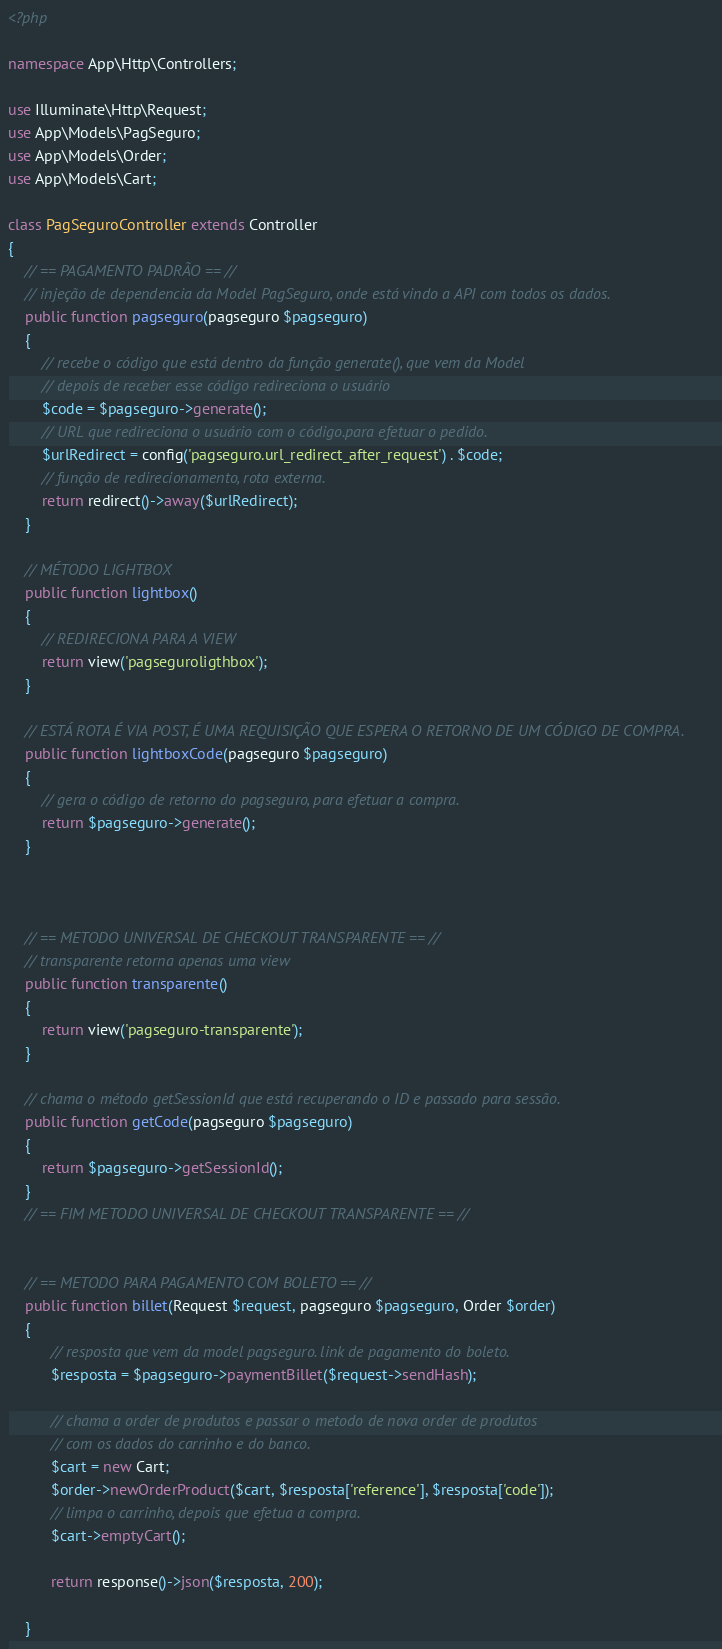Convert code to text. <code><loc_0><loc_0><loc_500><loc_500><_PHP_><?php

namespace App\Http\Controllers;

use Illuminate\Http\Request;
use App\Models\PagSeguro;
use App\Models\Order;
use App\Models\Cart;

class PagSeguroController extends Controller
{
    // == PAGAMENTO PADRÃO == //
    // injeção de dependencia da Model PagSeguro, onde está vindo a API com todos os dados.
    public function pagseguro(pagseguro $pagseguro)
    {
        // recebe o código que está dentro da função generate(), que vem da Model
        // depois de receber esse código redireciona o usuário
        $code = $pagseguro->generate();
        // URL que redireciona o usuário com o código.para efetuar o pedido.
        $urlRedirect = config('pagseguro.url_redirect_after_request') . $code;
        // função de redirecionamento, rota externa.
        return redirect()->away($urlRedirect);
    }

    // MÉTODO LIGHTBOX
    public function lightbox()
    {
        // REDIRECIONA PARA A VIEW 
        return view('pagseguroligthbox');
    }

    // ESTÁ ROTA É VIA POST, É UMA REQUISIÇÃO QUE ESPERA O RETORNO DE UM CÓDIGO DE COMPRA.
    public function lightboxCode(pagseguro $pagseguro)
    {
        // gera o código de retorno do pagseguro, para efetuar a compra.
        return $pagseguro->generate();
    }



    // == METODO UNIVERSAL DE CHECKOUT TRANSPARENTE == //
    // transparente retorna apenas uma view
    public function transparente()
    {
        return view('pagseguro-transparente');
    }

    // chama o método getSessionId que está recuperando o ID e passado para sessão.
    public function getCode(pagseguro $pagseguro)
    {
        return $pagseguro->getSessionId();
    }
    // == FIM METODO UNIVERSAL DE CHECKOUT TRANSPARENTE == //


    // == METODO PARA PAGAMENTO COM BOLETO == //
    public function billet(Request $request, pagseguro $pagseguro, Order $order)
    {
          // resposta que vem da model pagseguro. link de pagamento do boleto.  
          $resposta = $pagseguro->paymentBillet($request->sendHash);

          // chama a order de produtos e passar o metodo de nova order de produtos
          // com os dados do carrinho e do banco.
          $cart = new Cart;
          $order->newOrderProduct($cart, $resposta['reference'], $resposta['code']);
          // limpa o carrinho, depois que efetua a compra.
          $cart->emptyCart();

          return response()->json($resposta, 200);

    }</code> 